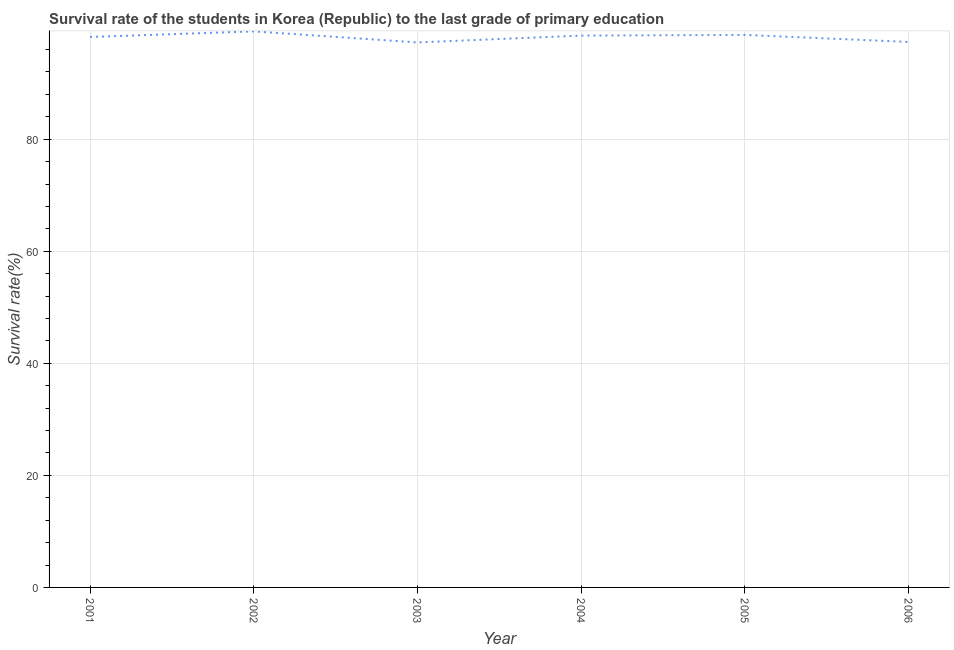What is the survival rate in primary education in 2001?
Your response must be concise. 98.25. Across all years, what is the maximum survival rate in primary education?
Keep it short and to the point. 99.24. Across all years, what is the minimum survival rate in primary education?
Keep it short and to the point. 97.27. What is the sum of the survival rate in primary education?
Give a very brief answer. 589.23. What is the difference between the survival rate in primary education in 2001 and 2004?
Provide a short and direct response. -0.25. What is the average survival rate in primary education per year?
Your answer should be compact. 98.21. What is the median survival rate in primary education?
Make the answer very short. 98.37. In how many years, is the survival rate in primary education greater than 64 %?
Offer a very short reply. 6. Do a majority of the years between 2001 and 2004 (inclusive) have survival rate in primary education greater than 80 %?
Make the answer very short. Yes. What is the ratio of the survival rate in primary education in 2001 to that in 2002?
Ensure brevity in your answer.  0.99. Is the survival rate in primary education in 2002 less than that in 2006?
Give a very brief answer. No. Is the difference between the survival rate in primary education in 2002 and 2003 greater than the difference between any two years?
Your response must be concise. Yes. What is the difference between the highest and the second highest survival rate in primary education?
Your response must be concise. 0.63. What is the difference between the highest and the lowest survival rate in primary education?
Offer a very short reply. 1.97. Does the survival rate in primary education monotonically increase over the years?
Your answer should be compact. No. Does the graph contain any zero values?
Your answer should be very brief. No. Does the graph contain grids?
Your response must be concise. Yes. What is the title of the graph?
Provide a short and direct response. Survival rate of the students in Korea (Republic) to the last grade of primary education. What is the label or title of the Y-axis?
Your answer should be very brief. Survival rate(%). What is the Survival rate(%) of 2001?
Offer a terse response. 98.25. What is the Survival rate(%) in 2002?
Offer a very short reply. 99.24. What is the Survival rate(%) of 2003?
Make the answer very short. 97.27. What is the Survival rate(%) in 2004?
Your response must be concise. 98.49. What is the Survival rate(%) in 2005?
Offer a terse response. 98.62. What is the Survival rate(%) in 2006?
Keep it short and to the point. 97.36. What is the difference between the Survival rate(%) in 2001 and 2002?
Offer a terse response. -1. What is the difference between the Survival rate(%) in 2001 and 2003?
Your response must be concise. 0.97. What is the difference between the Survival rate(%) in 2001 and 2004?
Make the answer very short. -0.25. What is the difference between the Survival rate(%) in 2001 and 2005?
Keep it short and to the point. -0.37. What is the difference between the Survival rate(%) in 2001 and 2006?
Offer a terse response. 0.89. What is the difference between the Survival rate(%) in 2002 and 2003?
Offer a very short reply. 1.97. What is the difference between the Survival rate(%) in 2002 and 2004?
Ensure brevity in your answer.  0.75. What is the difference between the Survival rate(%) in 2002 and 2005?
Give a very brief answer. 0.63. What is the difference between the Survival rate(%) in 2002 and 2006?
Ensure brevity in your answer.  1.89. What is the difference between the Survival rate(%) in 2003 and 2004?
Offer a very short reply. -1.22. What is the difference between the Survival rate(%) in 2003 and 2005?
Provide a succinct answer. -1.34. What is the difference between the Survival rate(%) in 2003 and 2006?
Make the answer very short. -0.09. What is the difference between the Survival rate(%) in 2004 and 2005?
Your answer should be very brief. -0.12. What is the difference between the Survival rate(%) in 2004 and 2006?
Offer a terse response. 1.13. What is the difference between the Survival rate(%) in 2005 and 2006?
Provide a short and direct response. 1.26. What is the ratio of the Survival rate(%) in 2001 to that in 2006?
Your answer should be compact. 1.01. What is the ratio of the Survival rate(%) in 2002 to that in 2004?
Give a very brief answer. 1.01. What is the ratio of the Survival rate(%) in 2002 to that in 2006?
Your answer should be very brief. 1.02. What is the ratio of the Survival rate(%) in 2003 to that in 2005?
Make the answer very short. 0.99. What is the ratio of the Survival rate(%) in 2004 to that in 2005?
Your answer should be compact. 1. 